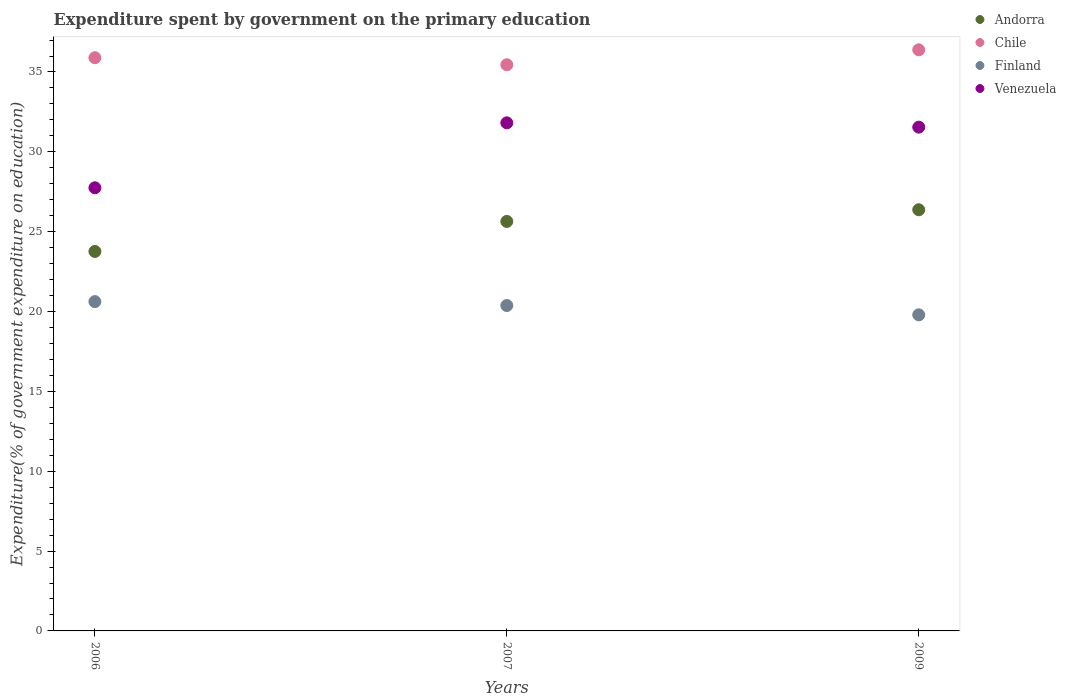How many different coloured dotlines are there?
Make the answer very short. 4. Is the number of dotlines equal to the number of legend labels?
Give a very brief answer. Yes. What is the expenditure spent by government on the primary education in Chile in 2006?
Ensure brevity in your answer.  35.89. Across all years, what is the maximum expenditure spent by government on the primary education in Chile?
Provide a short and direct response. 36.39. Across all years, what is the minimum expenditure spent by government on the primary education in Andorra?
Give a very brief answer. 23.76. In which year was the expenditure spent by government on the primary education in Finland maximum?
Provide a succinct answer. 2006. What is the total expenditure spent by government on the primary education in Venezuela in the graph?
Provide a succinct answer. 91.11. What is the difference between the expenditure spent by government on the primary education in Andorra in 2006 and that in 2007?
Your response must be concise. -1.88. What is the difference between the expenditure spent by government on the primary education in Finland in 2009 and the expenditure spent by government on the primary education in Andorra in 2007?
Keep it short and to the point. -5.85. What is the average expenditure spent by government on the primary education in Andorra per year?
Your response must be concise. 25.26. In the year 2007, what is the difference between the expenditure spent by government on the primary education in Andorra and expenditure spent by government on the primary education in Chile?
Keep it short and to the point. -9.81. What is the ratio of the expenditure spent by government on the primary education in Chile in 2006 to that in 2009?
Your answer should be very brief. 0.99. Is the expenditure spent by government on the primary education in Finland in 2006 less than that in 2009?
Offer a very short reply. No. Is the difference between the expenditure spent by government on the primary education in Andorra in 2006 and 2007 greater than the difference between the expenditure spent by government on the primary education in Chile in 2006 and 2007?
Offer a very short reply. No. What is the difference between the highest and the second highest expenditure spent by government on the primary education in Andorra?
Your answer should be very brief. 0.73. What is the difference between the highest and the lowest expenditure spent by government on the primary education in Andorra?
Your answer should be compact. 2.61. In how many years, is the expenditure spent by government on the primary education in Venezuela greater than the average expenditure spent by government on the primary education in Venezuela taken over all years?
Give a very brief answer. 2. Is the sum of the expenditure spent by government on the primary education in Venezuela in 2006 and 2009 greater than the maximum expenditure spent by government on the primary education in Finland across all years?
Provide a short and direct response. Yes. Is the expenditure spent by government on the primary education in Chile strictly less than the expenditure spent by government on the primary education in Venezuela over the years?
Make the answer very short. No. How many dotlines are there?
Your answer should be compact. 4. Does the graph contain any zero values?
Offer a very short reply. No. Does the graph contain grids?
Keep it short and to the point. No. Where does the legend appear in the graph?
Give a very brief answer. Top right. How many legend labels are there?
Offer a very short reply. 4. How are the legend labels stacked?
Ensure brevity in your answer.  Vertical. What is the title of the graph?
Ensure brevity in your answer.  Expenditure spent by government on the primary education. Does "New Zealand" appear as one of the legend labels in the graph?
Provide a short and direct response. No. What is the label or title of the Y-axis?
Your response must be concise. Expenditure(% of government expenditure on education). What is the Expenditure(% of government expenditure on education) in Andorra in 2006?
Ensure brevity in your answer.  23.76. What is the Expenditure(% of government expenditure on education) of Chile in 2006?
Your answer should be compact. 35.89. What is the Expenditure(% of government expenditure on education) of Finland in 2006?
Provide a succinct answer. 20.62. What is the Expenditure(% of government expenditure on education) in Venezuela in 2006?
Your response must be concise. 27.75. What is the Expenditure(% of government expenditure on education) of Andorra in 2007?
Offer a very short reply. 25.64. What is the Expenditure(% of government expenditure on education) in Chile in 2007?
Provide a succinct answer. 35.45. What is the Expenditure(% of government expenditure on education) of Finland in 2007?
Your answer should be very brief. 20.38. What is the Expenditure(% of government expenditure on education) in Venezuela in 2007?
Offer a very short reply. 31.81. What is the Expenditure(% of government expenditure on education) in Andorra in 2009?
Provide a succinct answer. 26.37. What is the Expenditure(% of government expenditure on education) in Chile in 2009?
Provide a short and direct response. 36.39. What is the Expenditure(% of government expenditure on education) of Finland in 2009?
Ensure brevity in your answer.  19.79. What is the Expenditure(% of government expenditure on education) in Venezuela in 2009?
Provide a succinct answer. 31.55. Across all years, what is the maximum Expenditure(% of government expenditure on education) in Andorra?
Your response must be concise. 26.37. Across all years, what is the maximum Expenditure(% of government expenditure on education) in Chile?
Your response must be concise. 36.39. Across all years, what is the maximum Expenditure(% of government expenditure on education) of Finland?
Your answer should be very brief. 20.62. Across all years, what is the maximum Expenditure(% of government expenditure on education) in Venezuela?
Offer a terse response. 31.81. Across all years, what is the minimum Expenditure(% of government expenditure on education) in Andorra?
Your answer should be very brief. 23.76. Across all years, what is the minimum Expenditure(% of government expenditure on education) of Chile?
Provide a short and direct response. 35.45. Across all years, what is the minimum Expenditure(% of government expenditure on education) in Finland?
Provide a succinct answer. 19.79. Across all years, what is the minimum Expenditure(% of government expenditure on education) of Venezuela?
Your response must be concise. 27.75. What is the total Expenditure(% of government expenditure on education) in Andorra in the graph?
Your answer should be very brief. 75.77. What is the total Expenditure(% of government expenditure on education) in Chile in the graph?
Keep it short and to the point. 107.73. What is the total Expenditure(% of government expenditure on education) of Finland in the graph?
Your answer should be compact. 60.79. What is the total Expenditure(% of government expenditure on education) in Venezuela in the graph?
Provide a short and direct response. 91.11. What is the difference between the Expenditure(% of government expenditure on education) of Andorra in 2006 and that in 2007?
Make the answer very short. -1.88. What is the difference between the Expenditure(% of government expenditure on education) in Chile in 2006 and that in 2007?
Provide a short and direct response. 0.44. What is the difference between the Expenditure(% of government expenditure on education) of Finland in 2006 and that in 2007?
Your response must be concise. 0.25. What is the difference between the Expenditure(% of government expenditure on education) of Venezuela in 2006 and that in 2007?
Offer a terse response. -4.07. What is the difference between the Expenditure(% of government expenditure on education) of Andorra in 2006 and that in 2009?
Your answer should be compact. -2.61. What is the difference between the Expenditure(% of government expenditure on education) in Chile in 2006 and that in 2009?
Offer a terse response. -0.49. What is the difference between the Expenditure(% of government expenditure on education) of Finland in 2006 and that in 2009?
Provide a short and direct response. 0.83. What is the difference between the Expenditure(% of government expenditure on education) in Venezuela in 2006 and that in 2009?
Your answer should be very brief. -3.8. What is the difference between the Expenditure(% of government expenditure on education) of Andorra in 2007 and that in 2009?
Give a very brief answer. -0.73. What is the difference between the Expenditure(% of government expenditure on education) of Chile in 2007 and that in 2009?
Ensure brevity in your answer.  -0.93. What is the difference between the Expenditure(% of government expenditure on education) of Finland in 2007 and that in 2009?
Provide a short and direct response. 0.58. What is the difference between the Expenditure(% of government expenditure on education) in Venezuela in 2007 and that in 2009?
Your answer should be compact. 0.27. What is the difference between the Expenditure(% of government expenditure on education) of Andorra in 2006 and the Expenditure(% of government expenditure on education) of Chile in 2007?
Give a very brief answer. -11.69. What is the difference between the Expenditure(% of government expenditure on education) in Andorra in 2006 and the Expenditure(% of government expenditure on education) in Finland in 2007?
Ensure brevity in your answer.  3.39. What is the difference between the Expenditure(% of government expenditure on education) in Andorra in 2006 and the Expenditure(% of government expenditure on education) in Venezuela in 2007?
Provide a succinct answer. -8.05. What is the difference between the Expenditure(% of government expenditure on education) in Chile in 2006 and the Expenditure(% of government expenditure on education) in Finland in 2007?
Ensure brevity in your answer.  15.52. What is the difference between the Expenditure(% of government expenditure on education) of Chile in 2006 and the Expenditure(% of government expenditure on education) of Venezuela in 2007?
Give a very brief answer. 4.08. What is the difference between the Expenditure(% of government expenditure on education) in Finland in 2006 and the Expenditure(% of government expenditure on education) in Venezuela in 2007?
Offer a very short reply. -11.19. What is the difference between the Expenditure(% of government expenditure on education) in Andorra in 2006 and the Expenditure(% of government expenditure on education) in Chile in 2009?
Your response must be concise. -12.62. What is the difference between the Expenditure(% of government expenditure on education) of Andorra in 2006 and the Expenditure(% of government expenditure on education) of Finland in 2009?
Offer a very short reply. 3.97. What is the difference between the Expenditure(% of government expenditure on education) in Andorra in 2006 and the Expenditure(% of government expenditure on education) in Venezuela in 2009?
Offer a very short reply. -7.78. What is the difference between the Expenditure(% of government expenditure on education) of Chile in 2006 and the Expenditure(% of government expenditure on education) of Finland in 2009?
Keep it short and to the point. 16.1. What is the difference between the Expenditure(% of government expenditure on education) of Chile in 2006 and the Expenditure(% of government expenditure on education) of Venezuela in 2009?
Give a very brief answer. 4.35. What is the difference between the Expenditure(% of government expenditure on education) of Finland in 2006 and the Expenditure(% of government expenditure on education) of Venezuela in 2009?
Offer a terse response. -10.93. What is the difference between the Expenditure(% of government expenditure on education) of Andorra in 2007 and the Expenditure(% of government expenditure on education) of Chile in 2009?
Provide a short and direct response. -10.75. What is the difference between the Expenditure(% of government expenditure on education) of Andorra in 2007 and the Expenditure(% of government expenditure on education) of Finland in 2009?
Give a very brief answer. 5.85. What is the difference between the Expenditure(% of government expenditure on education) in Andorra in 2007 and the Expenditure(% of government expenditure on education) in Venezuela in 2009?
Make the answer very short. -5.9. What is the difference between the Expenditure(% of government expenditure on education) of Chile in 2007 and the Expenditure(% of government expenditure on education) of Finland in 2009?
Your response must be concise. 15.66. What is the difference between the Expenditure(% of government expenditure on education) of Chile in 2007 and the Expenditure(% of government expenditure on education) of Venezuela in 2009?
Your answer should be compact. 3.91. What is the difference between the Expenditure(% of government expenditure on education) of Finland in 2007 and the Expenditure(% of government expenditure on education) of Venezuela in 2009?
Provide a short and direct response. -11.17. What is the average Expenditure(% of government expenditure on education) of Andorra per year?
Provide a short and direct response. 25.26. What is the average Expenditure(% of government expenditure on education) in Chile per year?
Your answer should be very brief. 35.91. What is the average Expenditure(% of government expenditure on education) of Finland per year?
Make the answer very short. 20.26. What is the average Expenditure(% of government expenditure on education) in Venezuela per year?
Offer a terse response. 30.37. In the year 2006, what is the difference between the Expenditure(% of government expenditure on education) in Andorra and Expenditure(% of government expenditure on education) in Chile?
Your answer should be very brief. -12.13. In the year 2006, what is the difference between the Expenditure(% of government expenditure on education) of Andorra and Expenditure(% of government expenditure on education) of Finland?
Give a very brief answer. 3.14. In the year 2006, what is the difference between the Expenditure(% of government expenditure on education) of Andorra and Expenditure(% of government expenditure on education) of Venezuela?
Your answer should be compact. -3.99. In the year 2006, what is the difference between the Expenditure(% of government expenditure on education) of Chile and Expenditure(% of government expenditure on education) of Finland?
Offer a terse response. 15.27. In the year 2006, what is the difference between the Expenditure(% of government expenditure on education) in Chile and Expenditure(% of government expenditure on education) in Venezuela?
Your answer should be compact. 8.14. In the year 2006, what is the difference between the Expenditure(% of government expenditure on education) of Finland and Expenditure(% of government expenditure on education) of Venezuela?
Keep it short and to the point. -7.13. In the year 2007, what is the difference between the Expenditure(% of government expenditure on education) in Andorra and Expenditure(% of government expenditure on education) in Chile?
Keep it short and to the point. -9.81. In the year 2007, what is the difference between the Expenditure(% of government expenditure on education) of Andorra and Expenditure(% of government expenditure on education) of Finland?
Your response must be concise. 5.27. In the year 2007, what is the difference between the Expenditure(% of government expenditure on education) in Andorra and Expenditure(% of government expenditure on education) in Venezuela?
Offer a terse response. -6.17. In the year 2007, what is the difference between the Expenditure(% of government expenditure on education) in Chile and Expenditure(% of government expenditure on education) in Finland?
Ensure brevity in your answer.  15.08. In the year 2007, what is the difference between the Expenditure(% of government expenditure on education) in Chile and Expenditure(% of government expenditure on education) in Venezuela?
Make the answer very short. 3.64. In the year 2007, what is the difference between the Expenditure(% of government expenditure on education) in Finland and Expenditure(% of government expenditure on education) in Venezuela?
Offer a very short reply. -11.44. In the year 2009, what is the difference between the Expenditure(% of government expenditure on education) in Andorra and Expenditure(% of government expenditure on education) in Chile?
Provide a short and direct response. -10.01. In the year 2009, what is the difference between the Expenditure(% of government expenditure on education) in Andorra and Expenditure(% of government expenditure on education) in Finland?
Your response must be concise. 6.58. In the year 2009, what is the difference between the Expenditure(% of government expenditure on education) in Andorra and Expenditure(% of government expenditure on education) in Venezuela?
Provide a short and direct response. -5.17. In the year 2009, what is the difference between the Expenditure(% of government expenditure on education) of Chile and Expenditure(% of government expenditure on education) of Finland?
Provide a short and direct response. 16.59. In the year 2009, what is the difference between the Expenditure(% of government expenditure on education) in Chile and Expenditure(% of government expenditure on education) in Venezuela?
Keep it short and to the point. 4.84. In the year 2009, what is the difference between the Expenditure(% of government expenditure on education) in Finland and Expenditure(% of government expenditure on education) in Venezuela?
Keep it short and to the point. -11.75. What is the ratio of the Expenditure(% of government expenditure on education) of Andorra in 2006 to that in 2007?
Your answer should be very brief. 0.93. What is the ratio of the Expenditure(% of government expenditure on education) of Chile in 2006 to that in 2007?
Offer a terse response. 1.01. What is the ratio of the Expenditure(% of government expenditure on education) of Venezuela in 2006 to that in 2007?
Your answer should be very brief. 0.87. What is the ratio of the Expenditure(% of government expenditure on education) in Andorra in 2006 to that in 2009?
Provide a short and direct response. 0.9. What is the ratio of the Expenditure(% of government expenditure on education) of Chile in 2006 to that in 2009?
Offer a very short reply. 0.99. What is the ratio of the Expenditure(% of government expenditure on education) of Finland in 2006 to that in 2009?
Ensure brevity in your answer.  1.04. What is the ratio of the Expenditure(% of government expenditure on education) in Venezuela in 2006 to that in 2009?
Your response must be concise. 0.88. What is the ratio of the Expenditure(% of government expenditure on education) of Andorra in 2007 to that in 2009?
Offer a very short reply. 0.97. What is the ratio of the Expenditure(% of government expenditure on education) of Chile in 2007 to that in 2009?
Offer a terse response. 0.97. What is the ratio of the Expenditure(% of government expenditure on education) in Finland in 2007 to that in 2009?
Give a very brief answer. 1.03. What is the ratio of the Expenditure(% of government expenditure on education) of Venezuela in 2007 to that in 2009?
Ensure brevity in your answer.  1.01. What is the difference between the highest and the second highest Expenditure(% of government expenditure on education) of Andorra?
Provide a short and direct response. 0.73. What is the difference between the highest and the second highest Expenditure(% of government expenditure on education) in Chile?
Provide a short and direct response. 0.49. What is the difference between the highest and the second highest Expenditure(% of government expenditure on education) in Finland?
Provide a short and direct response. 0.25. What is the difference between the highest and the second highest Expenditure(% of government expenditure on education) in Venezuela?
Offer a very short reply. 0.27. What is the difference between the highest and the lowest Expenditure(% of government expenditure on education) in Andorra?
Your answer should be compact. 2.61. What is the difference between the highest and the lowest Expenditure(% of government expenditure on education) in Chile?
Make the answer very short. 0.93. What is the difference between the highest and the lowest Expenditure(% of government expenditure on education) of Finland?
Give a very brief answer. 0.83. What is the difference between the highest and the lowest Expenditure(% of government expenditure on education) of Venezuela?
Keep it short and to the point. 4.07. 